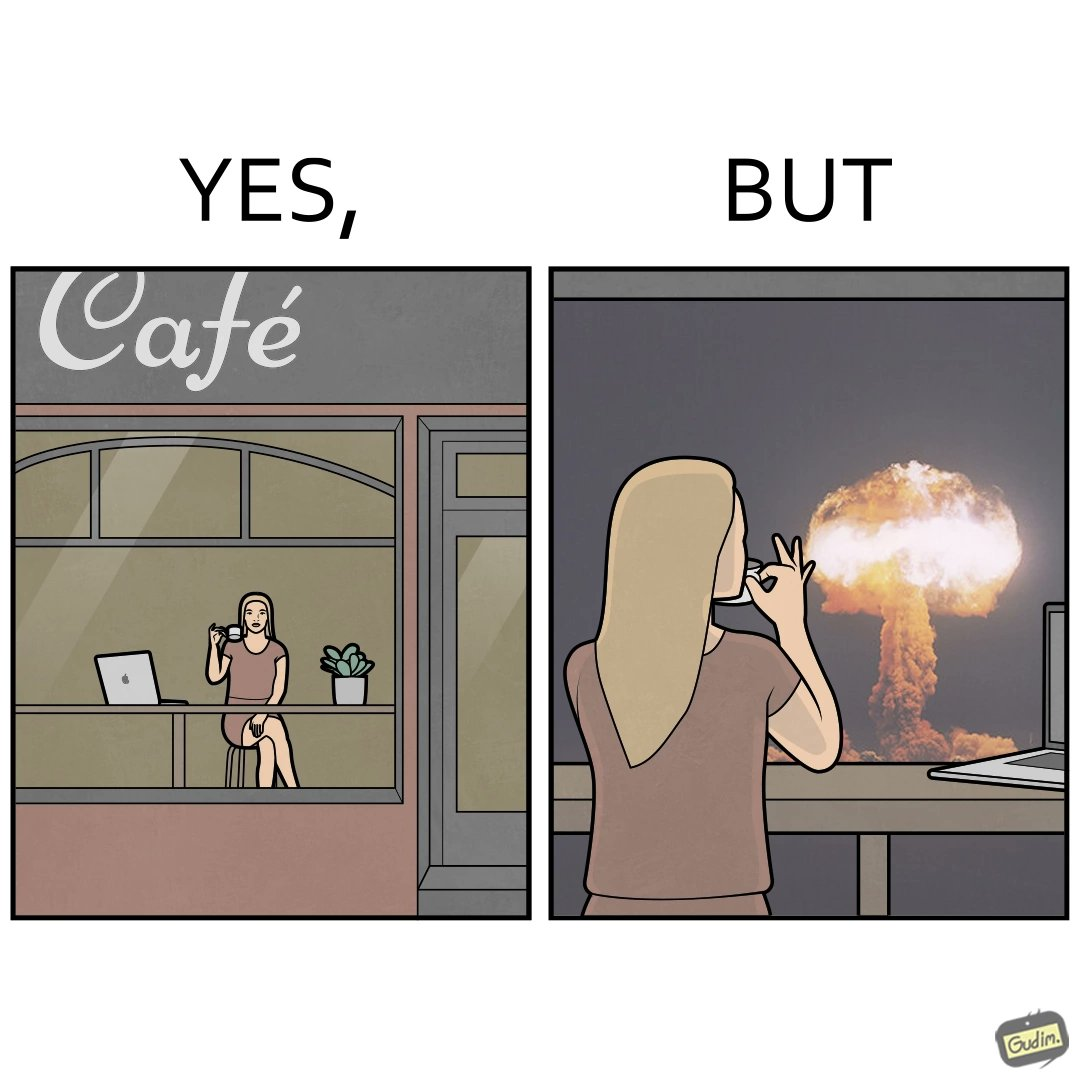Describe the content of this image. The images are funny since it shows a woman simply sipping from a cup at ease in a cafe with her laptop not caring about anything going on outside the cafe even though the situation is very grave,that is, a nuclear blast 